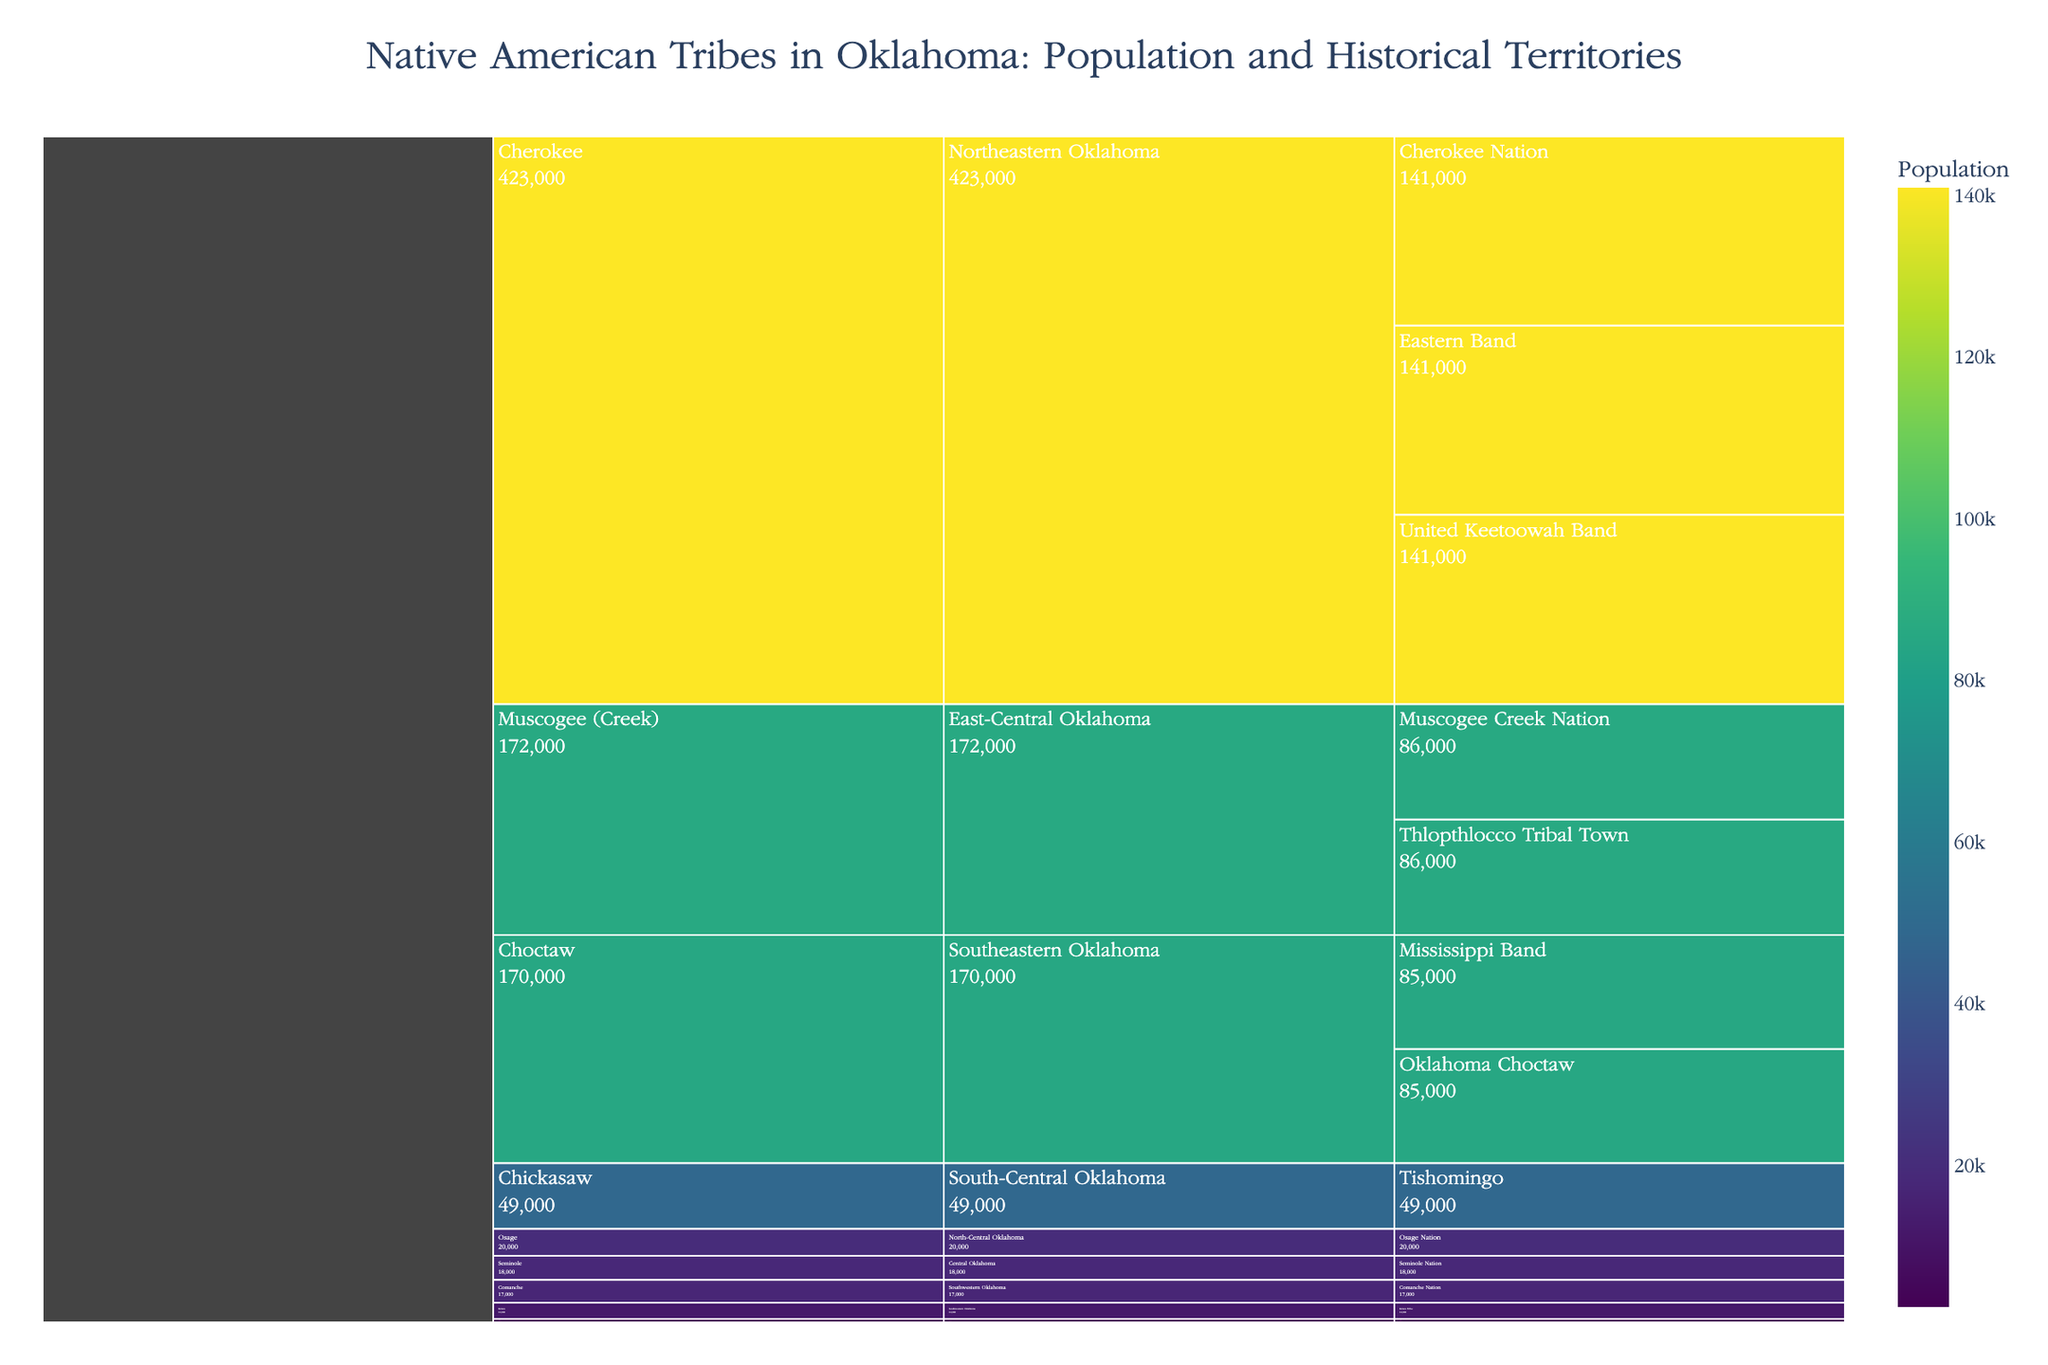Which tribe has the highest population? To determine this, look for the segment with the tallest bar under the "Population" value color-coded on the icicle chart. The Cherokee Tribe stands out as having the largest population among the options.
Answer: Cherokee How many sub-groups are there for the Choctaw tribe? Count the distinct sections nested under the "Choctaw" label in the icicle chart. There are two visible sub-groups: Mississippi Band and Oklahoma Choctaw.
Answer: 2 Which tribe historically occupied the North-Central Oklahoma territory? Locate the section labeled "North-Central Oklahoma" and trace it back to the tribal label at the higher hierarchy, which is "Osage."
Answer: Osage What is the combined population of the Muscogee (Creek) Tribe? Sum the populations of the Muscogee sub-groups: Muscogee Creek Nation (86,000) and Thlopthlocco Tribal Town (86,000). The total is 172,000.
Answer: 172,000 Compare the population between the Comanche and Kiowa tribes. Which one is larger? Look at the heights of the bars under the labels "Comanche" and "Kiowa" and compare their values: Comanche (17,000) vs. Kiowa (12,000). The Comanche population is larger.
Answer: Comanche What is the total population of all tribes shown in the figure? Sum all the population values listed for each tribe and their sub-groups in the icicle chart. Total = 141,000 (Cherokee) * 3 + 85,000 (Choctaw) * 2 + 49,000 (Chickasaw) + 86,000 (Muscogee) * 2 + 18,000 (Seminole) + 20,000 (Osage) + 17,000 (Comanche) + 12,000 (Kiowa) + 2,600 (Apache) = 897,600.
Answer: 897,600 Which tribe's sub-group is affiliated with the Tishomingo historical territory? Identify the "Tishomingo" territory in the icicle chart and trace it back to its tribal association. It is linked to the Chickasaw Tribe.
Answer: Chickasaw What is the smallest sub-group population listed, and which tribe does it belong to? Scan for the smallest population value within the icicle chart. The smallest is 2,600, linked to the Apache Tribe's sub-group "Apache Tribe of Oklahoma."
Answer: Apache Tribe of Oklahoma, 2,600 How does the population of the Seminole Nation compare to that of the Osage Nation? Look at the icicle chart bars for each sub-group and compare their populations: Seminole Nation (18,000) vs. Osage Nation (20,000). The Osage Nation is larger.
Answer: Osage Nation What historical territory hosts the highest combined population, and what is the population? Aggregate the population values for each tribe within each historical territory and compare. The Northeastern Oklahoma historical territory includes the Cherokee Tribe sub-groups with a combined population of 141,000 * 3 = 423,000, the highest among all listed territories.
Answer: Northeastern Oklahoma, 423,000 